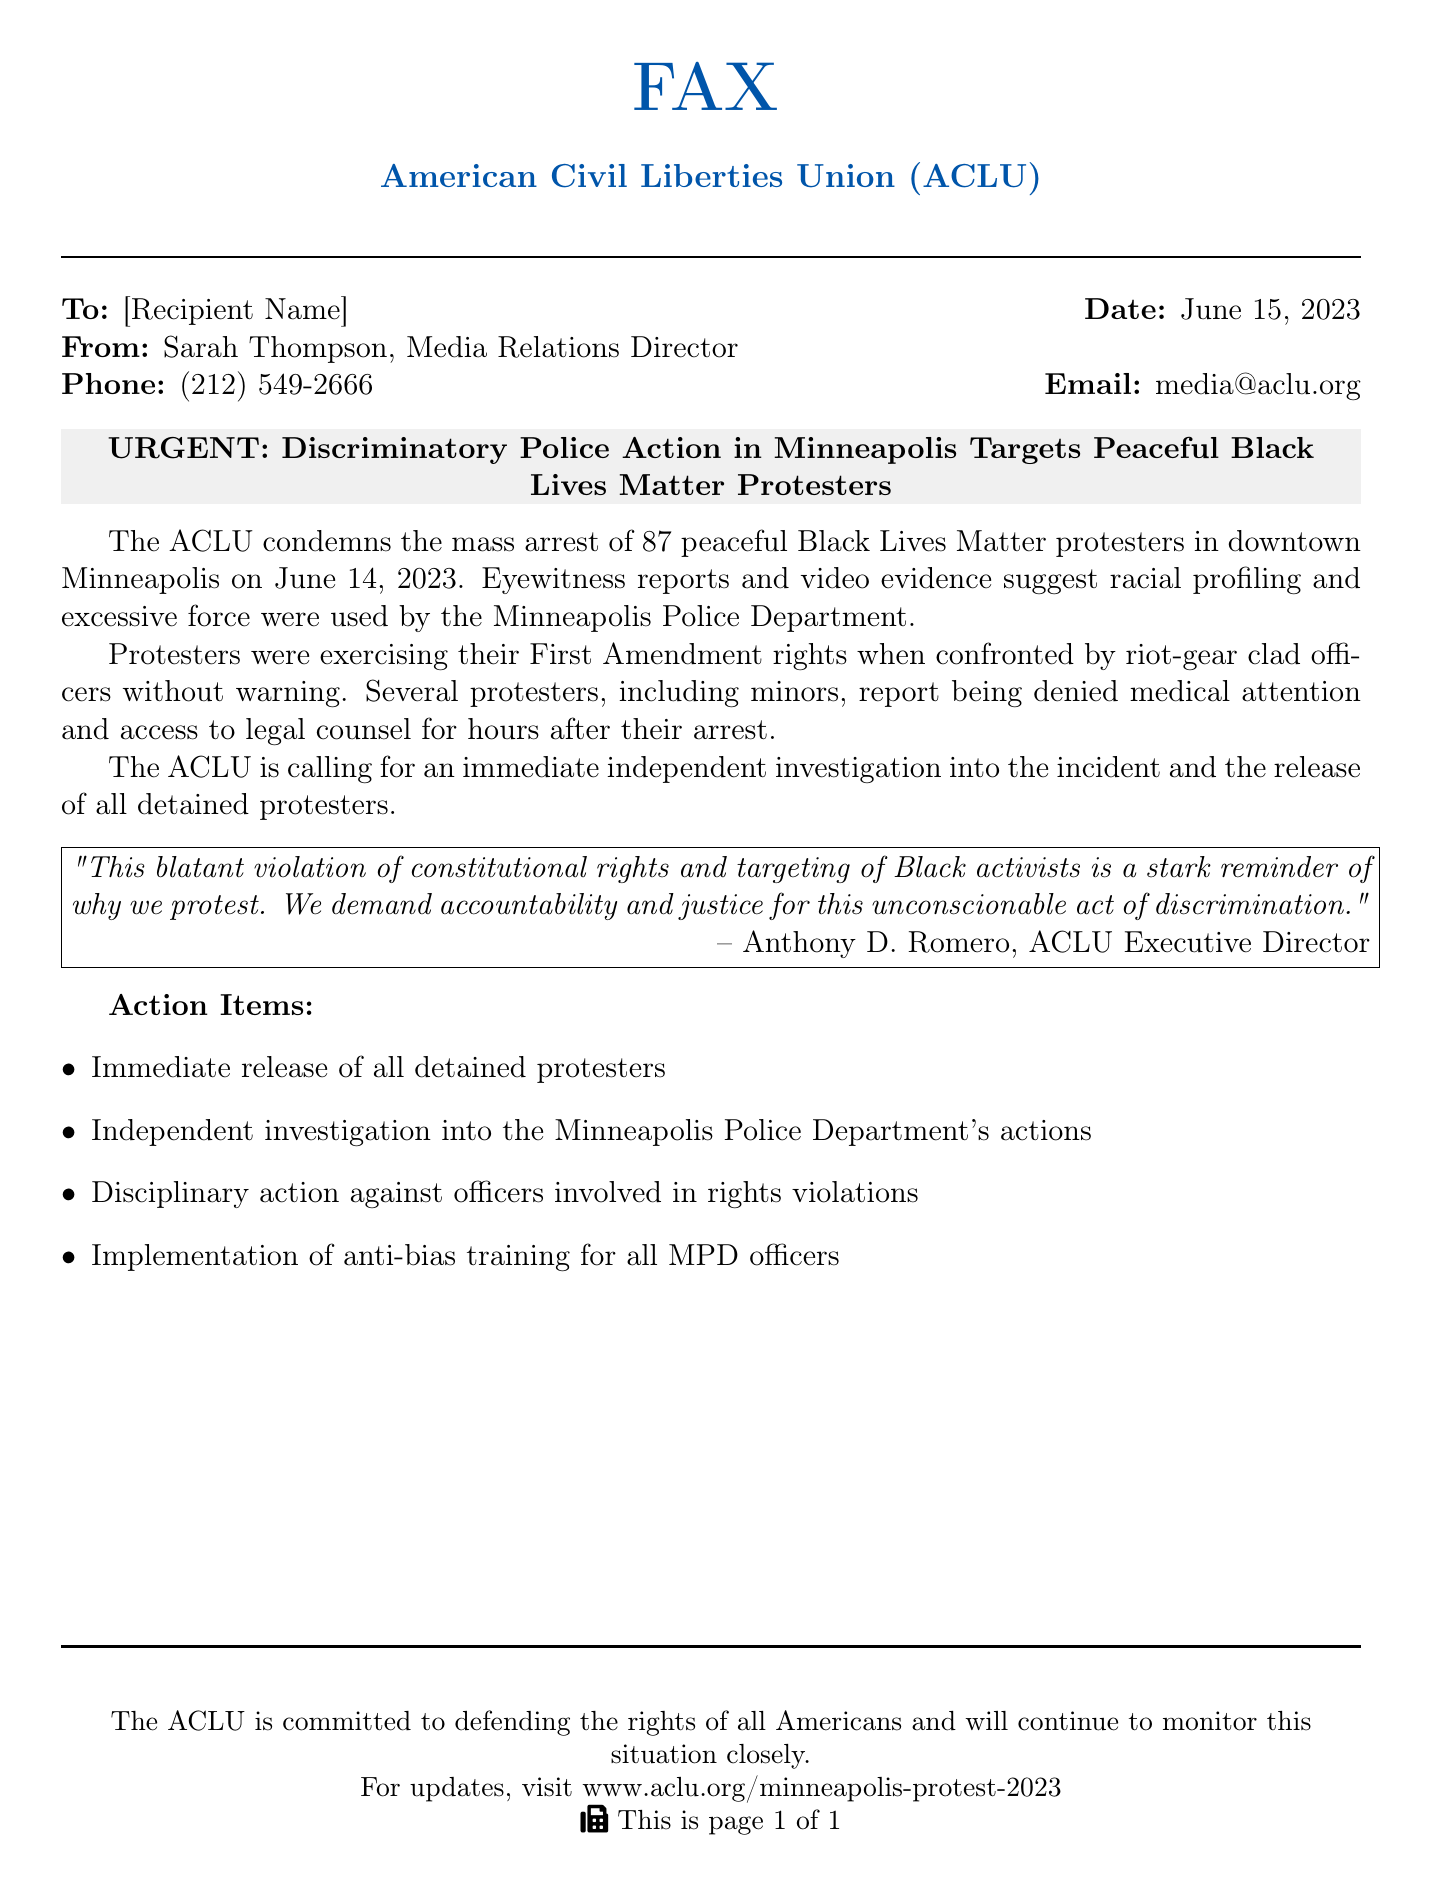What organization issued the press release? The organization that issued the press release is listed at the top of the document.
Answer: American Civil Liberties Union (ACLU) What incident is being condemned in the press release? The incident being condemned is highlighted in the title and the body of the document.
Answer: mass arrest of 87 peaceful Black Lives Matter protesters On what date did the incident occur? The date of the incident is mentioned in the document body.
Answer: June 14, 2023 What is the number of protesters arrested? The number of arrested protesters is specified in the document.
Answer: 87 Who is the ACLU Executive Director? The Executive Director's name is given in the quoted statement at the bottom of the page.
Answer: Anthony D. Romero What action does the ACLU demand regarding the detained protesters? The document states a specific action related to the detained protesters.
Answer: immediate release What are the protesters exercising when they were confronted by police? The right being exercised by the protesters is clearly articulated.
Answer: First Amendment rights What type of training does the ACLU call for to be implemented for the police officers? The type of training requested is mentioned in the action items.
Answer: anti-bias training What does ACLU stand for? The full name of the ACLU is indicated in the organization heading.
Answer: American Civil Liberties Union 